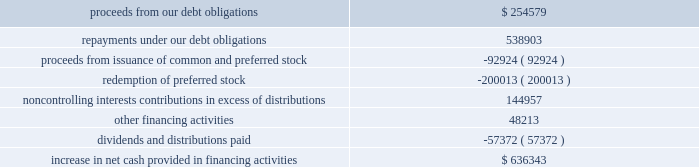Sl green realty corp .
It happens here 2012 annual report 59 | 59 during the year ended december a031 , 2012 , when compared to the year ended december a031 , 2011 , we used cash for the follow- ing financing activities ( in thousands ) : .
Ca pita liz ation | as of december a0 31 , 2012 , we had 91249632 shares of common stock , 2759758 units of lim- ited partnership interest in the operating partnership held by persons other than the company , 66668 a0 performance based ltip units , 7700000 a0 shares of our 7.625% ( 7.625 % ) series a0 c cumulative redeemable preferred stock , or series c preferred stock , and 9200000 a0 shares of our 6.50% ( 6.50 % ) series a0 i cumula- tive redeemable preferred stock , or series a0 i preferred stock , outstanding .
In addition , we also had preferred units of limited partnership interests in the operating partnership having aggregate liquidation preferences of $ 49.6 a0million held by per- sons other than the company .
In september a0 2012 , we redeemed 4000000 a0 shares , or $ 100.0 a0 million , of series c preferred stock at a redemp- tion price of $ 25.00 a0 per share plus a0 $ 0.3707 in accumu- lated and unpaid dividends on such preferred stock through september a0 24 , 2012 .
We recognized $ 6.3 a0 million of costs to partially redeem the series c preferred stock .
As a result of this redemption , we have 7700000 a0 shares of series a0 c preferred stock outstanding .
In august a0 2012 , we issued 9200000 a0 shares of our series a0 i preferred stock with a mandatory liquidation pref- erence of $ 25.00 a0 per share .
The series a0 i preferred share- holders receive annual distributions of $ 1.625 a0per share paid on a quarterly basis and distributions are cumulative , sub- ject to certain provisions .
We are entitled to redeem our series a0i preferred stock at par for cash at our option on or after august a0 10 , 2017 .
Net proceeds from the series i preferred stock ( $ 222.2 a0million ) was recorded net of underwriters 2019 dis- count and issuance a0costs .
In july a0 2012 , we redeemed all 4000000 a0 shares , or $ 100.0 a0million , of our 7.875% ( 7.875 % ) series a0d cumulative redeemable preferred stock , or series a0d preferred stock , at a redemption price of $ 25.00 a0 per share plus $ 0.4922 in accumulated and unpaid dividends on such preferred stock through july a0 14 , 2012 .
We recognized $ 3.7 a0million of costs to fully redeem the series a0d preferred stock .
In july a0 2011 , we , along with the operating partnership , entered into an 201cat-the-market 201d equity offering program , or atm program , to sell an aggregate of $ 250.0 a0 million of our common stock .
During the year ended december a0 31 , 2012 , we sold 2.6 a0 million shares of our common stock through the atm program for aggregate gross proceeds of approximately $ 204.6 a0 million ( $ 201.3 a0 million of net proceeds after related expenses ) .
The net proceeds were used to repay debt , fund new investments and for other corporate purposes .
As of december a0 31 , 2012 , we had $ 45.4 a0 million available to issue under the atm a0program .
Dividend reinvestment and stock purchase plan | in march a0 2012 , we filed a registration statement with the sec for our dividend reinvestment and stock purchase plan , or drip , which automatically became effective upon filing .
We registered 3500000 a0shares of common stock under the drip .
The drip commenced on september a024 , 2001 .
During the years ended december a0 31 , 2012 and 2011 , we issued approximately 1.3 a0 million and 473 a0 shares of our common stock and received approximately $ 99.6 a0million and $ 34000 of net proceeds , respectively , from dividend reinvest- ments and/or stock purchases under the drip .
Drip shares may be issued at a discount to the market price .
Second amended and restated 2005 stock option and incentive plan | subject to adjustments upon cer- tain corporate transactions or events , up to a maximum of 10730000 a0 fungible units may be granted as options , restricted stock , phantom shares , dividend equivalent rights and other equity based awards under the second amended and restated 2005 a0 stock option and incentive plan , or the 2005 a0plan .
As of december a031 , 2012 , no fungible units were available for issuance under the 2005 a0plan after reserving for shares underlying outstanding restricted stock units , phantom stock units granted pursuant to our non-employee directors 2019 deferral program and ltip units , including , among others , outstanding ltip units issued under our 2011 a0 long-term outperformance plan , which remain subject to performance based a0vesting .
2005 long-ter m outper for m a nce compensation program | in december a0 2005 , the compensation commit- tee of our board of directors approved a long-term incentive compensation program , the 2005 a0 outperformance plan .
Participants in the 2005 a0 outperformance plan were enti- tled to earn ltip a0 units in our operating partnership if our total return to stockholders for the three-year period beginning december a0 1 , 2005 exceeded a cumulative total return to stockholders of 30% ( 30 % ) ; provided that participants were entitled to earn ltip units earlier in the event that we achieved maximum performance for 30 consecutive days .
On june a014 , 2006 , the compensation committee determined that under the terms of the 2005 a0 outperformance plan , as of june a0 8 , 2006 , the performance period had accelerated and the maximum performance pool of $ 49250000 , taking into account forfeitures , had been earned .
Under the terms of the 2005 a0 outperformance plan , participants also earned additional ltip a0units with a value equal to the distributions .
In 000 , what were proceeds from our debt obligations net of repayments under our debt obligations? 
Computations: (254579 - 538903)
Answer: -284324.0. 